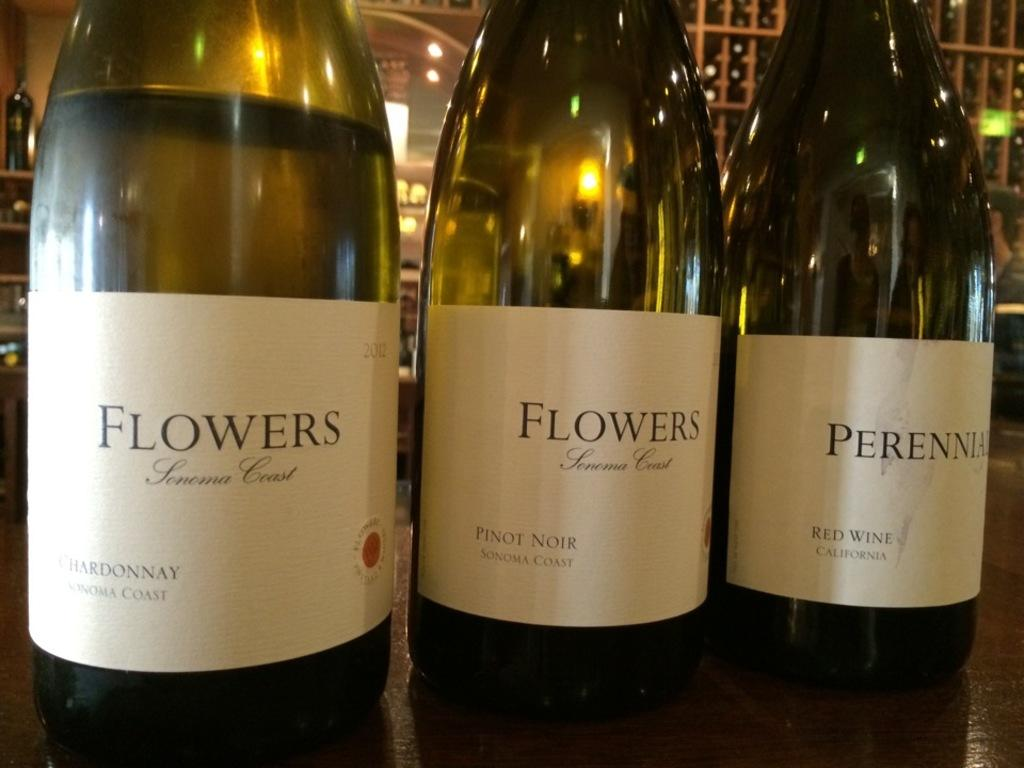<image>
Create a compact narrative representing the image presented. A row of wine bottles say Flowers Chardonnay. 